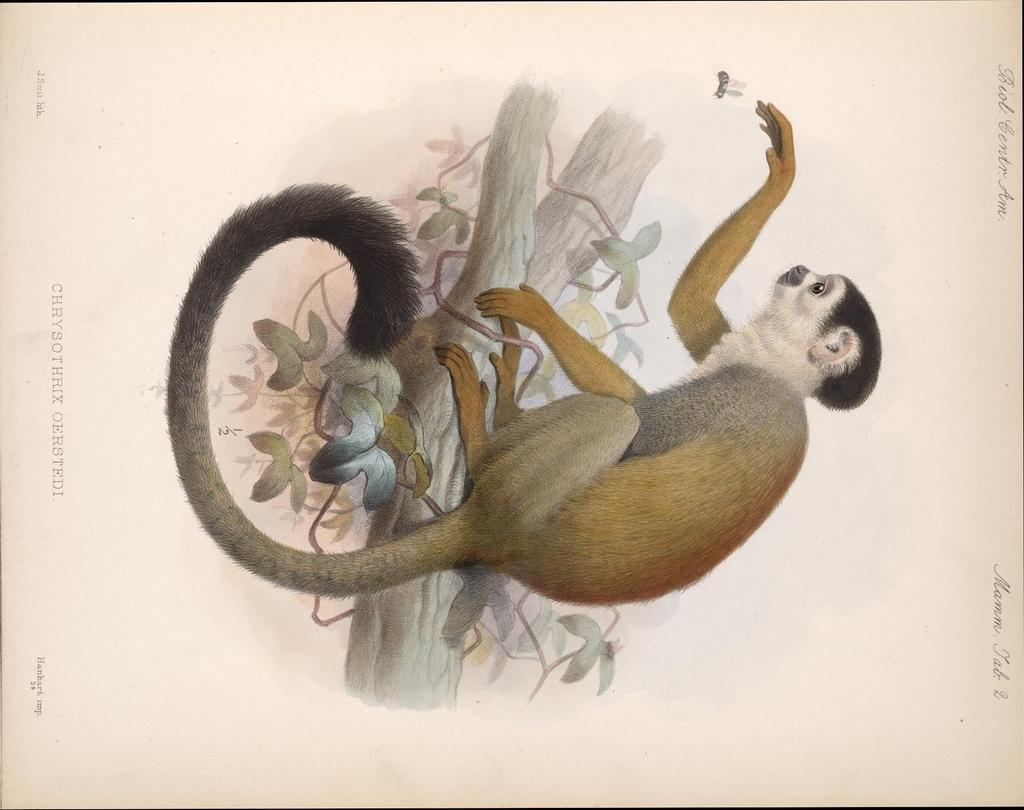What type of artwork is depicted in the image? The image is a painting. What is the main subject of the painting? There is a monkey in the center of the painting. Where is the monkey located in the painting? The monkey is on a tree. What can be seen on the sides of the painting? There is text on both the right and left sides of the painting. How many pages does the dock have in the image? There is no dock present in the image, so it is not possible to determine the number of pages it might have. 